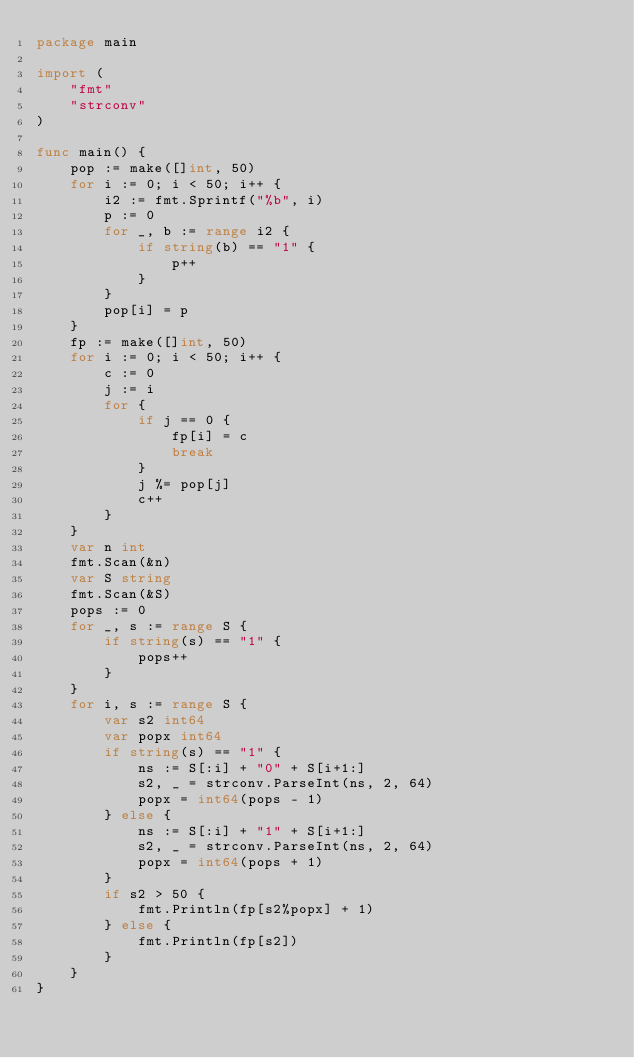<code> <loc_0><loc_0><loc_500><loc_500><_Go_>package main

import (
	"fmt"
	"strconv"
)

func main() {
	pop := make([]int, 50)
	for i := 0; i < 50; i++ {
		i2 := fmt.Sprintf("%b", i)
		p := 0
		for _, b := range i2 {
			if string(b) == "1" {
				p++
			}
		}
		pop[i] = p
	}
	fp := make([]int, 50)
	for i := 0; i < 50; i++ {
		c := 0
		j := i
		for {
			if j == 0 {
				fp[i] = c
				break
			}
			j %= pop[j]
			c++
		}
	}
	var n int
	fmt.Scan(&n)
	var S string
	fmt.Scan(&S)
	pops := 0
	for _, s := range S {
		if string(s) == "1" {
			pops++
		}
	}
	for i, s := range S {
		var s2 int64
		var popx int64
		if string(s) == "1" {
			ns := S[:i] + "0" + S[i+1:]
			s2, _ = strconv.ParseInt(ns, 2, 64)
			popx = int64(pops - 1)
		} else {
			ns := S[:i] + "1" + S[i+1:]
			s2, _ = strconv.ParseInt(ns, 2, 64)
			popx = int64(pops + 1)
		}
		if s2 > 50 {
			fmt.Println(fp[s2%popx] + 1)
		} else {
			fmt.Println(fp[s2])
		}
	}
}
</code> 